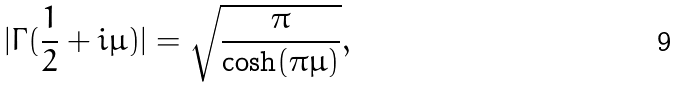Convert formula to latex. <formula><loc_0><loc_0><loc_500><loc_500>| \Gamma ( { \frac { 1 } { 2 } + i \mu } ) | = \sqrt { \frac { \pi } { \cosh ( \pi \mu ) } } ,</formula> 